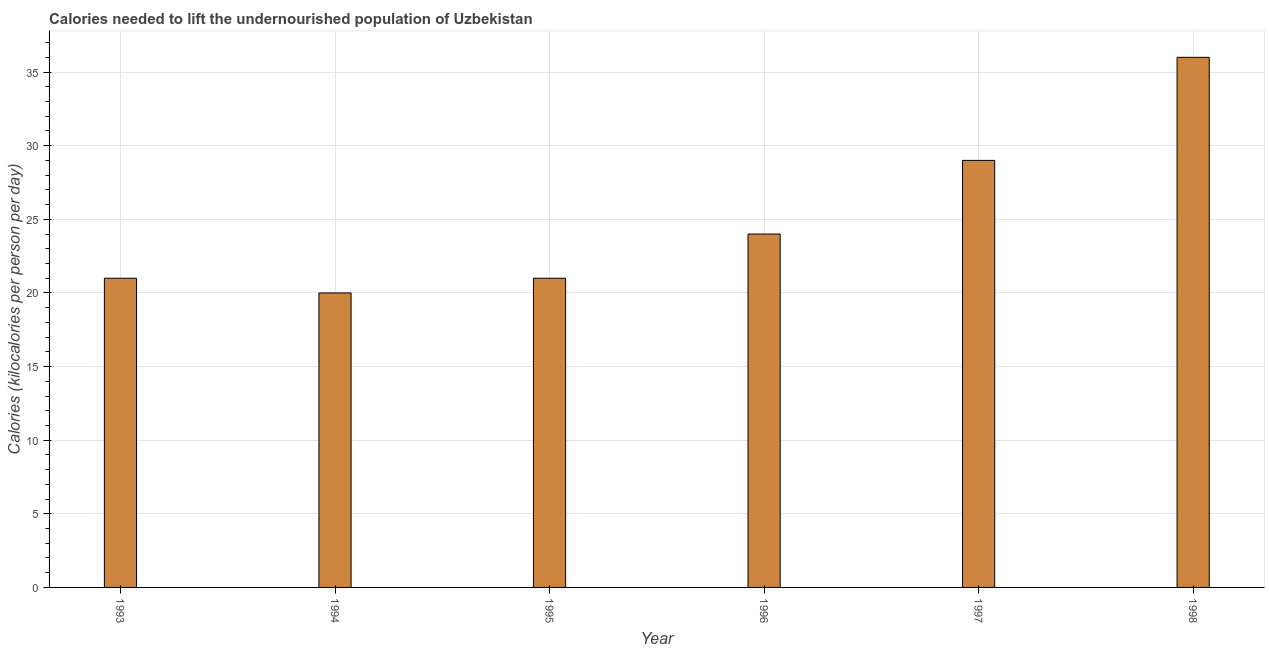Does the graph contain any zero values?
Give a very brief answer. No. Does the graph contain grids?
Offer a very short reply. Yes. What is the title of the graph?
Give a very brief answer. Calories needed to lift the undernourished population of Uzbekistan. What is the label or title of the X-axis?
Give a very brief answer. Year. What is the label or title of the Y-axis?
Your response must be concise. Calories (kilocalories per person per day). What is the depth of food deficit in 1993?
Provide a succinct answer. 21. Across all years, what is the maximum depth of food deficit?
Make the answer very short. 36. Across all years, what is the minimum depth of food deficit?
Give a very brief answer. 20. What is the sum of the depth of food deficit?
Offer a terse response. 151. What is the average depth of food deficit per year?
Keep it short and to the point. 25. What is the median depth of food deficit?
Provide a succinct answer. 22.5. Do a majority of the years between 1995 and 1997 (inclusive) have depth of food deficit greater than 27 kilocalories?
Your answer should be very brief. No. What is the difference between the highest and the second highest depth of food deficit?
Give a very brief answer. 7. How many years are there in the graph?
Offer a very short reply. 6. Are the values on the major ticks of Y-axis written in scientific E-notation?
Your answer should be very brief. No. What is the Calories (kilocalories per person per day) of 1997?
Offer a terse response. 29. What is the difference between the Calories (kilocalories per person per day) in 1993 and 1994?
Provide a succinct answer. 1. What is the difference between the Calories (kilocalories per person per day) in 1993 and 1995?
Your answer should be compact. 0. What is the difference between the Calories (kilocalories per person per day) in 1994 and 1995?
Give a very brief answer. -1. What is the difference between the Calories (kilocalories per person per day) in 1994 and 1997?
Keep it short and to the point. -9. What is the difference between the Calories (kilocalories per person per day) in 1995 and 1996?
Provide a succinct answer. -3. What is the difference between the Calories (kilocalories per person per day) in 1995 and 1997?
Give a very brief answer. -8. What is the difference between the Calories (kilocalories per person per day) in 1996 and 1998?
Your response must be concise. -12. What is the difference between the Calories (kilocalories per person per day) in 1997 and 1998?
Keep it short and to the point. -7. What is the ratio of the Calories (kilocalories per person per day) in 1993 to that in 1996?
Offer a terse response. 0.88. What is the ratio of the Calories (kilocalories per person per day) in 1993 to that in 1997?
Offer a very short reply. 0.72. What is the ratio of the Calories (kilocalories per person per day) in 1993 to that in 1998?
Provide a short and direct response. 0.58. What is the ratio of the Calories (kilocalories per person per day) in 1994 to that in 1996?
Make the answer very short. 0.83. What is the ratio of the Calories (kilocalories per person per day) in 1994 to that in 1997?
Keep it short and to the point. 0.69. What is the ratio of the Calories (kilocalories per person per day) in 1994 to that in 1998?
Your answer should be very brief. 0.56. What is the ratio of the Calories (kilocalories per person per day) in 1995 to that in 1996?
Provide a short and direct response. 0.88. What is the ratio of the Calories (kilocalories per person per day) in 1995 to that in 1997?
Provide a short and direct response. 0.72. What is the ratio of the Calories (kilocalories per person per day) in 1995 to that in 1998?
Ensure brevity in your answer.  0.58. What is the ratio of the Calories (kilocalories per person per day) in 1996 to that in 1997?
Offer a very short reply. 0.83. What is the ratio of the Calories (kilocalories per person per day) in 1996 to that in 1998?
Offer a very short reply. 0.67. What is the ratio of the Calories (kilocalories per person per day) in 1997 to that in 1998?
Make the answer very short. 0.81. 